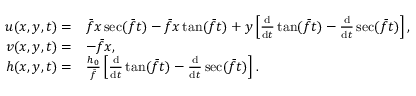<formula> <loc_0><loc_0><loc_500><loc_500>\begin{array} { r l } { u ( x , y , t ) = } & { \bar { f } x \sec ( \bar { f } t ) - \bar { f } x \tan ( \bar { f } t ) + y \left [ \frac { d } { d t } \tan ( \bar { f } t ) - \frac { d } { d t } \sec ( \bar { f } t ) \right ] , } \\ { v ( x , y , t ) = } & { - \bar { f } x , } \\ { h ( x , y , t ) = } & { \frac { h _ { 0 } } { \bar { f } } \left [ \frac { d } { d t } \tan ( \bar { f } t ) - \frac { d } { d t } \sec ( \bar { f } t ) \right ] . } \end{array}</formula> 